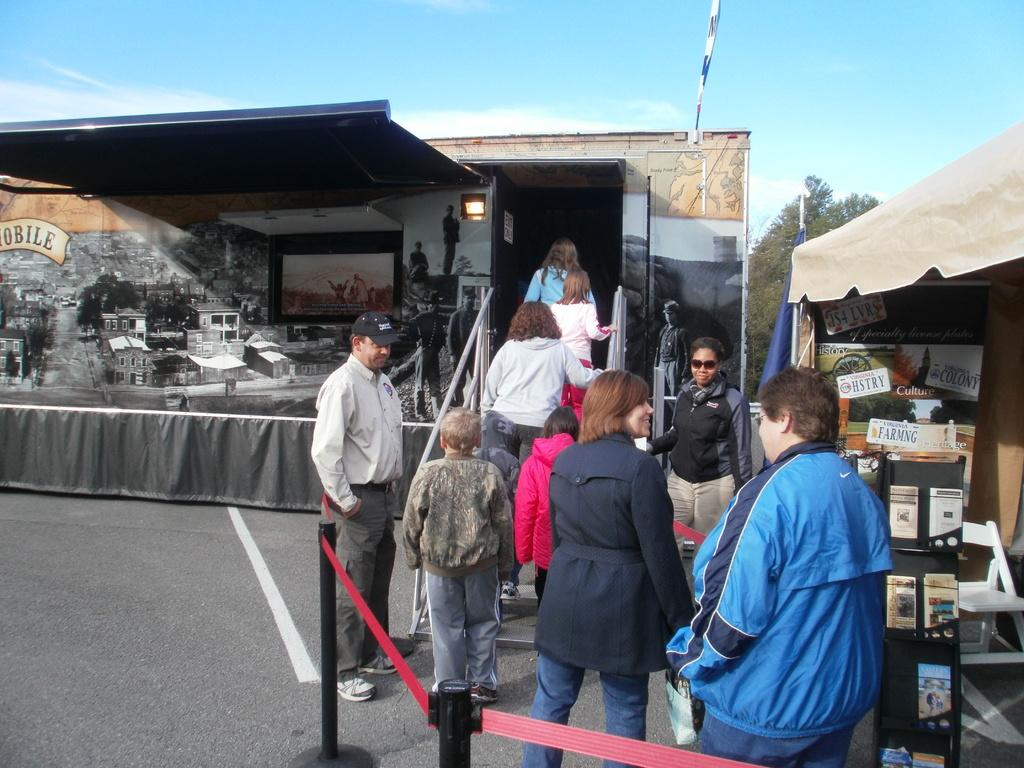Provide a one-sentence caption for the provided image. People are lined up to enter a trailer, passing a tent with information about Virginia history as they wait. 